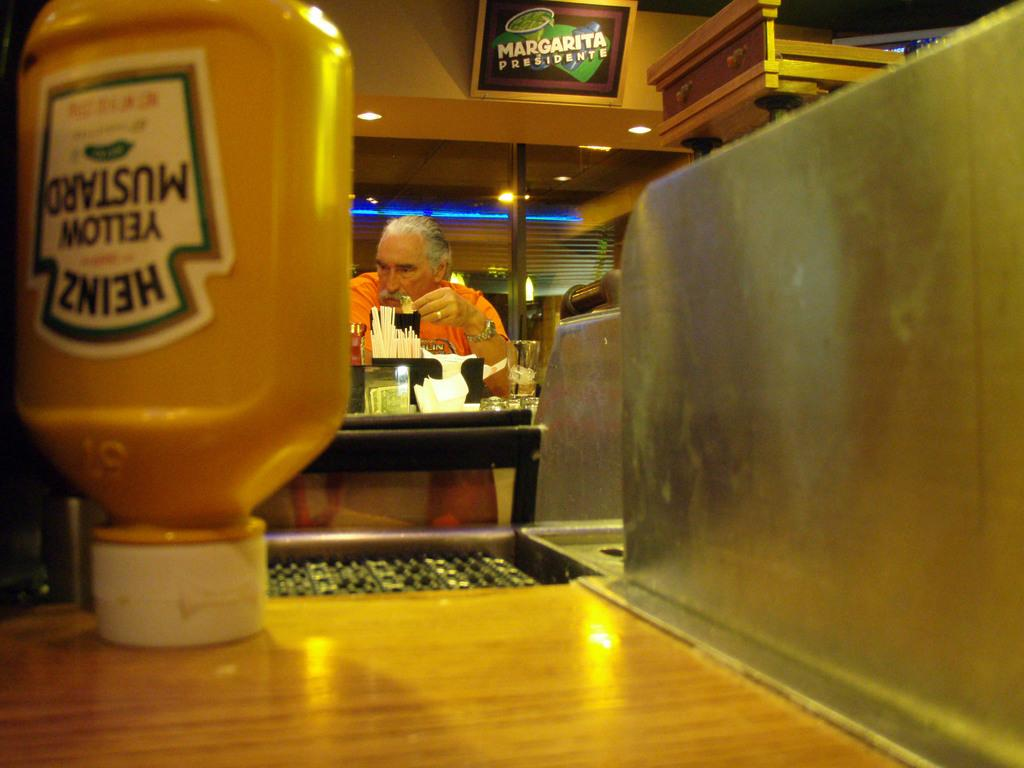<image>
Provide a brief description of the given image. A bottle of Heinz yellow mustard placed upside down. 